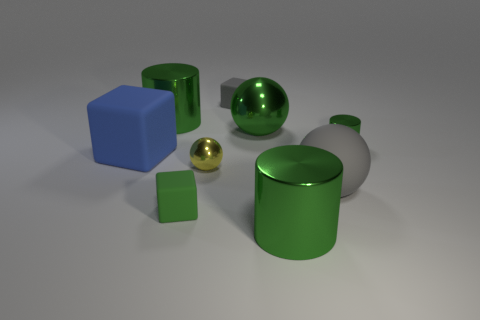Subtract all gray rubber spheres. How many spheres are left? 2 Subtract all yellow balls. How many balls are left? 2 Subtract 2 spheres. How many spheres are left? 1 Subtract all yellow cylinders. How many red spheres are left? 0 Subtract all large balls. Subtract all big green shiny things. How many objects are left? 4 Add 1 rubber blocks. How many rubber blocks are left? 4 Add 5 big cylinders. How many big cylinders exist? 7 Subtract 0 brown cylinders. How many objects are left? 9 Subtract all cubes. How many objects are left? 6 Subtract all gray cylinders. Subtract all brown cubes. How many cylinders are left? 3 